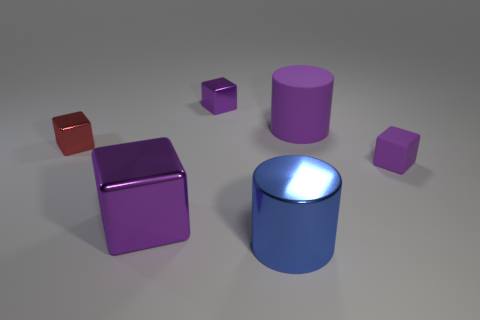How many purple blocks must be subtracted to get 1 purple blocks? 2 Subtract all metal cubes. How many cubes are left? 1 Subtract all yellow spheres. How many purple cubes are left? 3 Subtract all red cubes. How many cubes are left? 3 Add 1 green cylinders. How many objects exist? 7 Subtract all cylinders. How many objects are left? 4 Add 1 small purple matte things. How many small purple matte things exist? 2 Subtract 0 brown blocks. How many objects are left? 6 Subtract all gray cubes. Subtract all cyan cylinders. How many cubes are left? 4 Subtract all red rubber spheres. Subtract all big purple rubber objects. How many objects are left? 5 